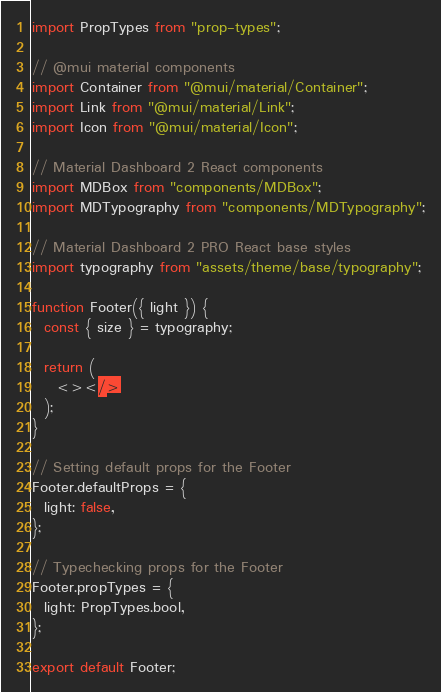Convert code to text. <code><loc_0><loc_0><loc_500><loc_500><_JavaScript_>import PropTypes from "prop-types";

// @mui material components
import Container from "@mui/material/Container";
import Link from "@mui/material/Link";
import Icon from "@mui/material/Icon";

// Material Dashboard 2 React components
import MDBox from "components/MDBox";
import MDTypography from "components/MDTypography";

// Material Dashboard 2 PRO React base styles
import typography from "assets/theme/base/typography";

function Footer({ light }) {
  const { size } = typography;

  return (
    <></>
  );
}

// Setting default props for the Footer
Footer.defaultProps = {
  light: false,
};

// Typechecking props for the Footer
Footer.propTypes = {
  light: PropTypes.bool,
};

export default Footer;
</code> 